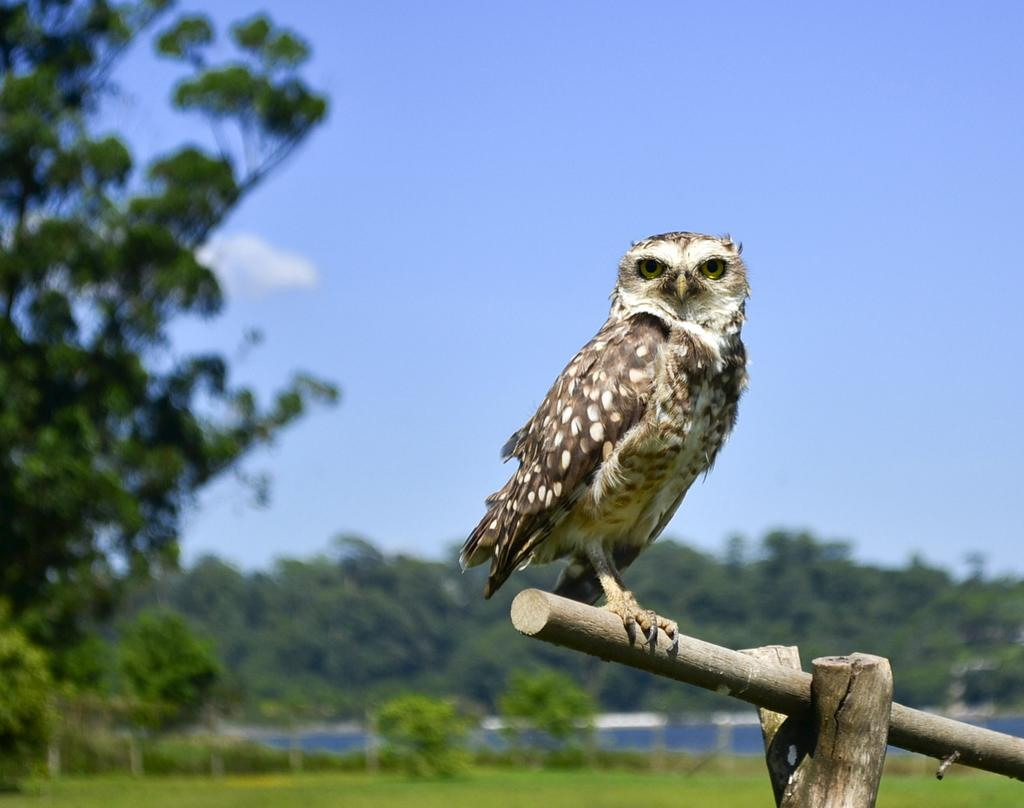What animal is present in the image? There is an owl in the image. What is the owl standing on? The owl is standing on a stick. What type of vegetation can be seen in the image? There are plants and trees visible in the image. How many pies are being served on the chairs in the image? There are no pies or chairs present in the image; it features an owl standing on a stick with plants and trees visible in the background. 